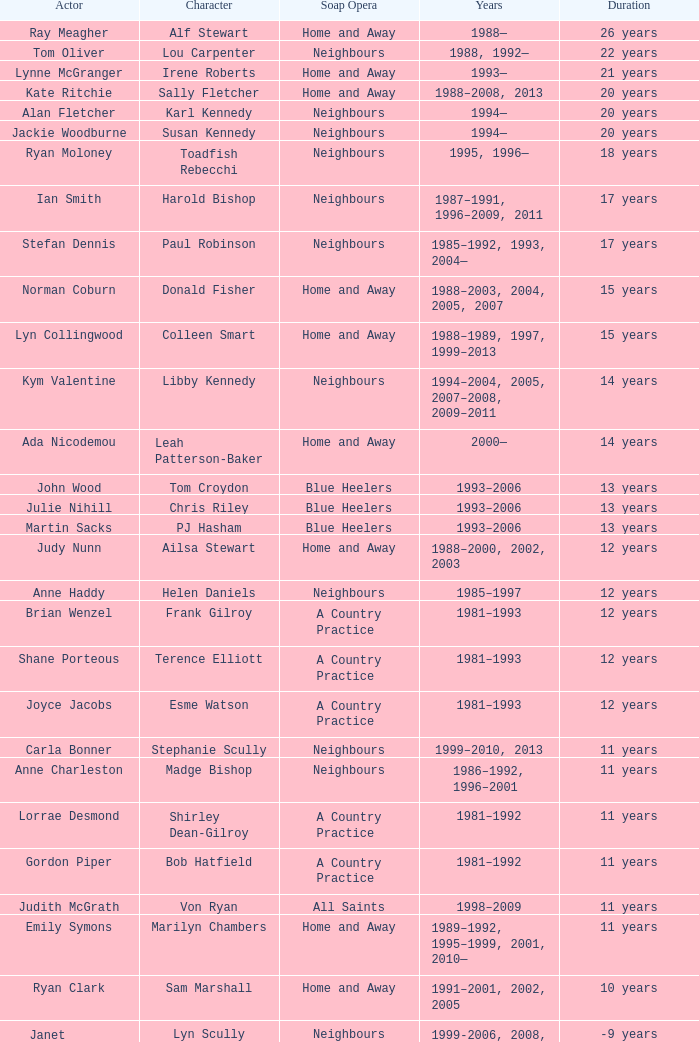How long did Joyce Jacobs portray her character on her show? 12 years. 